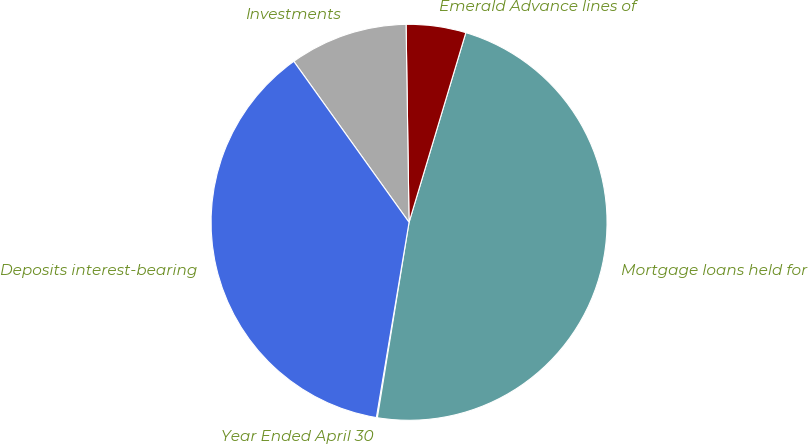<chart> <loc_0><loc_0><loc_500><loc_500><pie_chart><fcel>Year Ended April 30<fcel>Mortgage loans held for<fcel>Emerald Advance lines of<fcel>Investments<fcel>Deposits interest-bearing<nl><fcel>0.08%<fcel>47.93%<fcel>4.87%<fcel>9.65%<fcel>37.47%<nl></chart> 